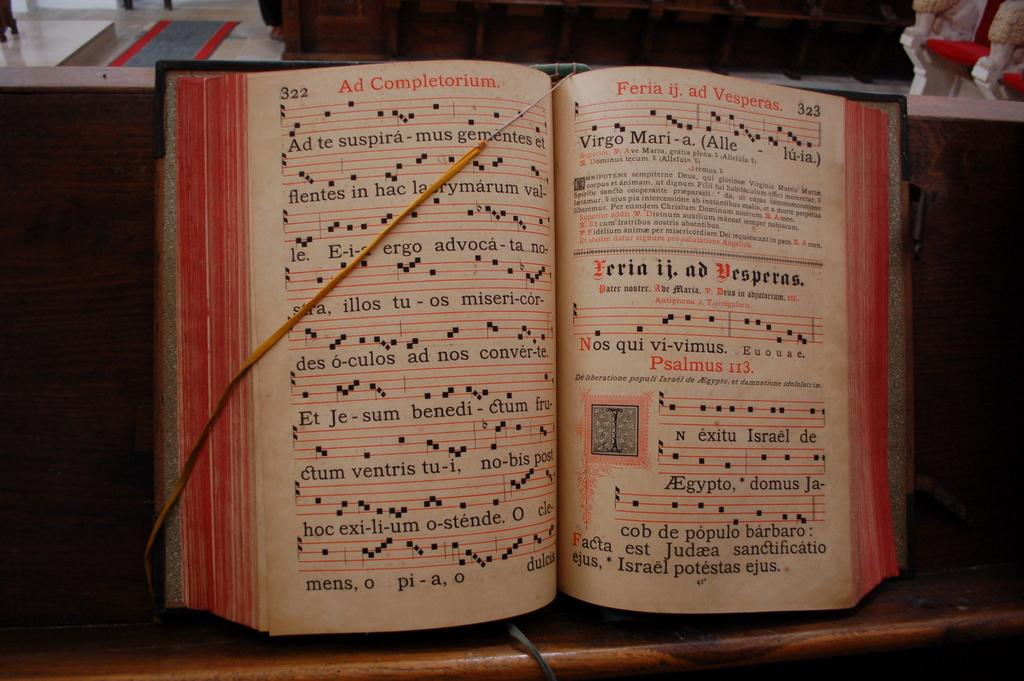<image>
Relay a brief, clear account of the picture shown. A music book is opened to a page that includes Psalmus 113. 